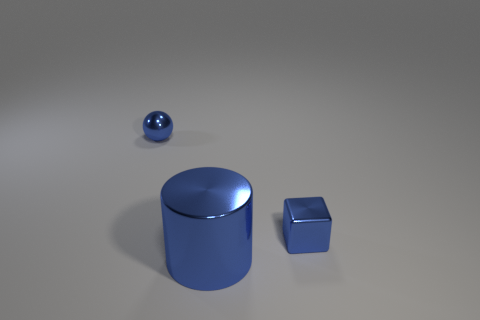Is there anything else that has the same size as the blue cylinder?
Offer a very short reply. No. Are there the same number of blue shiny spheres that are right of the large cylinder and big purple metal things?
Make the answer very short. Yes. How big is the shiny cylinder?
Your answer should be compact. Large. What number of metallic spheres are the same color as the big shiny cylinder?
Make the answer very short. 1. Is the blue cube the same size as the ball?
Keep it short and to the point. Yes. There is a blue object in front of the tiny blue thing to the right of the big metal cylinder; how big is it?
Offer a terse response. Large. Is the color of the metal ball the same as the tiny thing that is to the right of the tiny shiny ball?
Make the answer very short. Yes. Is there a blue shiny sphere of the same size as the blue cube?
Ensure brevity in your answer.  Yes. There is a blue object to the left of the large object; what size is it?
Your response must be concise. Small. Is there a metallic object in front of the small blue shiny thing that is on the right side of the small blue ball?
Your answer should be very brief. Yes. 